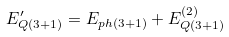<formula> <loc_0><loc_0><loc_500><loc_500>E ^ { \prime } _ { Q ( 3 + 1 ) } = E _ { p h ( 3 + 1 ) } + E ^ { ( 2 ) } _ { Q ( 3 + 1 ) }</formula> 